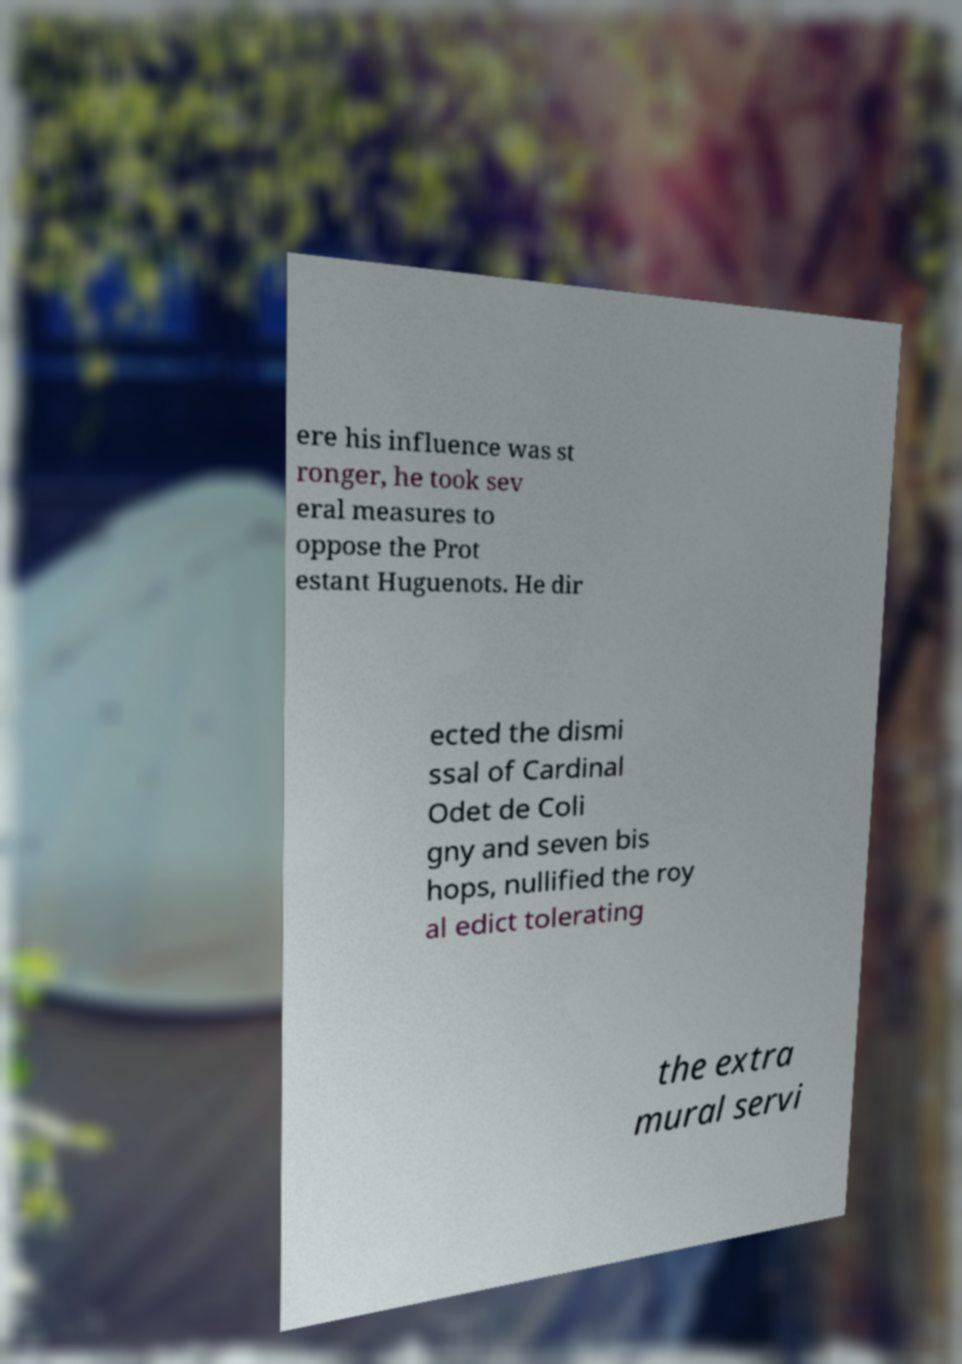I need the written content from this picture converted into text. Can you do that? ere his influence was st ronger, he took sev eral measures to oppose the Prot estant Huguenots. He dir ected the dismi ssal of Cardinal Odet de Coli gny and seven bis hops, nullified the roy al edict tolerating the extra mural servi 